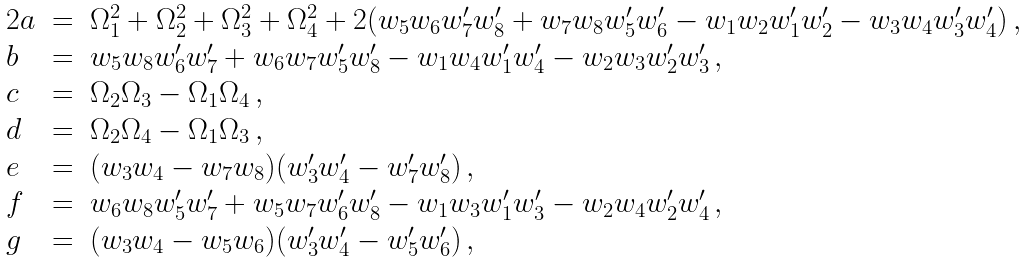Convert formula to latex. <formula><loc_0><loc_0><loc_500><loc_500>\begin{array} { l l l } 2 a & = & \Omega _ { 1 } ^ { 2 } + \Omega _ { 2 } ^ { 2 } + \Omega _ { 3 } ^ { 2 } + \Omega _ { 4 } ^ { 2 } + 2 ( w _ { 5 } w _ { 6 } w _ { 7 } ^ { \prime } w _ { 8 } ^ { \prime } + w _ { 7 } w _ { 8 } w _ { 5 } ^ { \prime } w _ { 6 } ^ { \prime } - w _ { 1 } w _ { 2 } w _ { 1 } ^ { \prime } w _ { 2 } ^ { \prime } - w _ { 3 } w _ { 4 } w _ { 3 } ^ { \prime } w _ { 4 } ^ { \prime } ) \, , \\ b & = & w _ { 5 } w _ { 8 } w _ { 6 } ^ { \prime } w _ { 7 } ^ { \prime } + w _ { 6 } w _ { 7 } w _ { 5 } ^ { \prime } w _ { 8 } ^ { \prime } - w _ { 1 } w _ { 4 } w _ { 1 } ^ { \prime } w _ { 4 } ^ { \prime } - w _ { 2 } w _ { 3 } w _ { 2 } ^ { \prime } w _ { 3 } ^ { \prime } \, , \\ c & = & \Omega _ { 2 } \Omega _ { 3 } - \Omega _ { 1 } \Omega _ { 4 } \, , \\ d & = & \Omega _ { 2 } \Omega _ { 4 } - \Omega _ { 1 } \Omega _ { 3 } \, , \\ e & = & ( w _ { 3 } w _ { 4 } - w _ { 7 } w _ { 8 } ) ( w _ { 3 } ^ { \prime } w _ { 4 } ^ { \prime } - w _ { 7 } ^ { \prime } w _ { 8 } ^ { \prime } ) \, , \\ f & = & w _ { 6 } w _ { 8 } w _ { 5 } ^ { \prime } w _ { 7 } ^ { \prime } + w _ { 5 } w _ { 7 } w _ { 6 } ^ { \prime } w _ { 8 } ^ { \prime } - w _ { 1 } w _ { 3 } w _ { 1 } ^ { \prime } w _ { 3 } ^ { \prime } - w _ { 2 } w _ { 4 } w _ { 2 } ^ { \prime } w _ { 4 } ^ { \prime } \, , \\ g & = & ( w _ { 3 } w _ { 4 } - w _ { 5 } w _ { 6 } ) ( w _ { 3 } ^ { \prime } w _ { 4 } ^ { \prime } - w _ { 5 } ^ { \prime } w _ { 6 } ^ { \prime } ) \, , \end{array}</formula> 